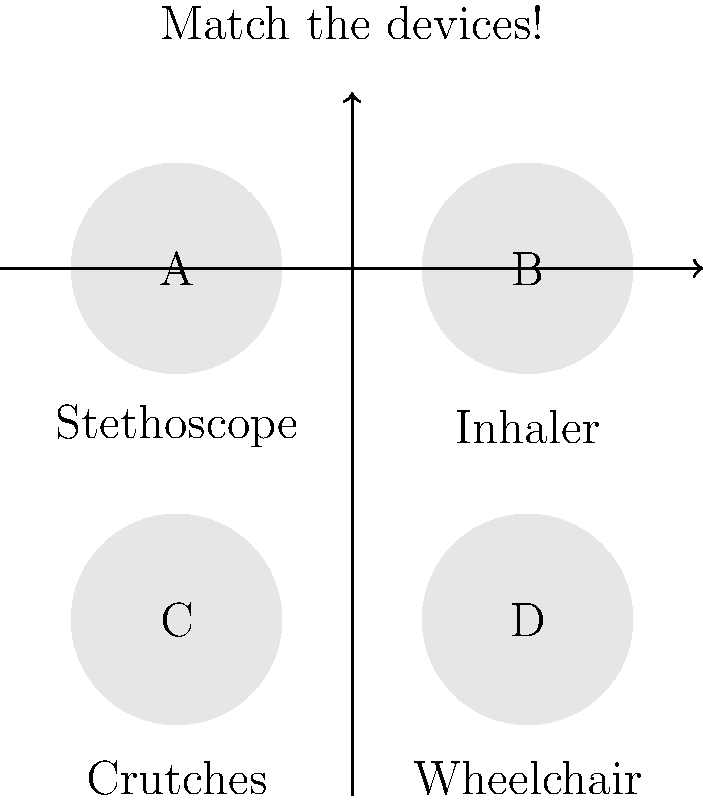Can you match the medical devices to their correct names? Draw a line connecting each letter to the correct device name.

A. Wheelchair
B. Stethoscope
C. Inhaler
D. Crutches Let's go through each device and match it to the correct name:

1. Device A is a circular object with wheels, used to help people move around when they can't walk. This matches the description of a Wheelchair.

2. Device B is a long tube with ear pieces at one end and a circular piece at the other. Doctors use this to listen to your heart and lungs. This is a Stethoscope.

3. Device C is a small, hand-held device that people use to breathe in medicine. This device is an Inhaler.

4. Device D shows two long sticks with handles and arm supports. These help people walk when they have an injured leg or foot. These are Crutches.

By matching each device to its description and function, we can connect the letters to the correct names.
Answer: A-Wheelchair, B-Stethoscope, C-Inhaler, D-Crutches 